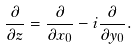Convert formula to latex. <formula><loc_0><loc_0><loc_500><loc_500>\frac { \partial } { \partial z } = \frac { \partial } { \partial x _ { 0 } } - i \frac { \partial } { \partial y _ { 0 } } .</formula> 